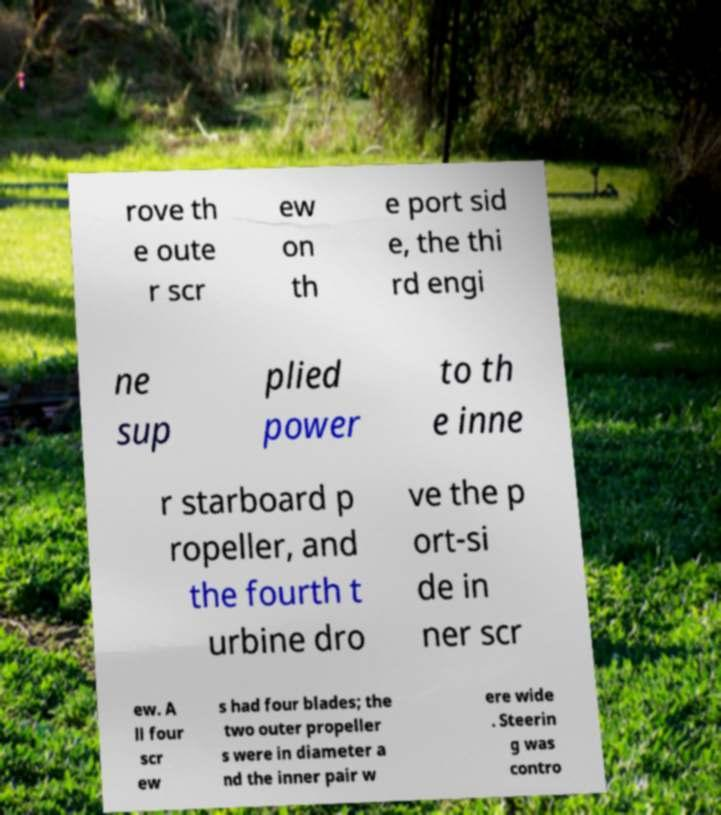Could you assist in decoding the text presented in this image and type it out clearly? rove th e oute r scr ew on th e port sid e, the thi rd engi ne sup plied power to th e inne r starboard p ropeller, and the fourth t urbine dro ve the p ort-si de in ner scr ew. A ll four scr ew s had four blades; the two outer propeller s were in diameter a nd the inner pair w ere wide . Steerin g was contro 